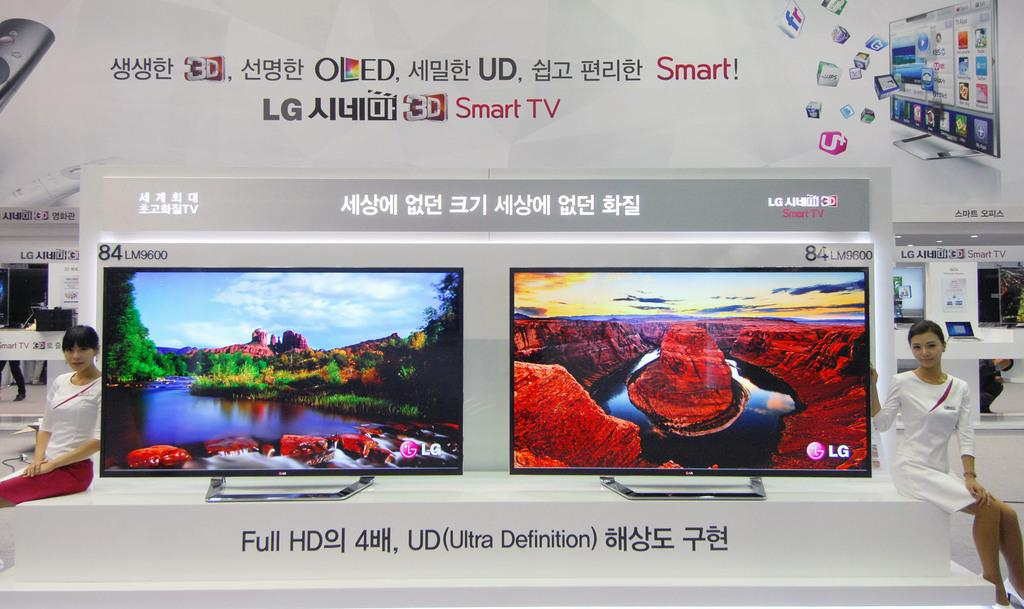<image>
Write a terse but informative summary of the picture. An ad with Asian writing features Smart TVs. 